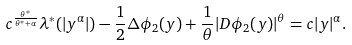<formula> <loc_0><loc_0><loc_500><loc_500>c ^ { \frac { \theta ^ { * } } { \theta ^ { * } + \alpha } } \lambda ^ { * } ( | y ^ { \alpha } | ) - \frac { 1 } { 2 } \Delta \phi _ { 2 } ( y ) + \frac { 1 } { \theta } | D \phi _ { 2 } ( y ) | ^ { \theta } = c | y | ^ { \alpha } .</formula> 